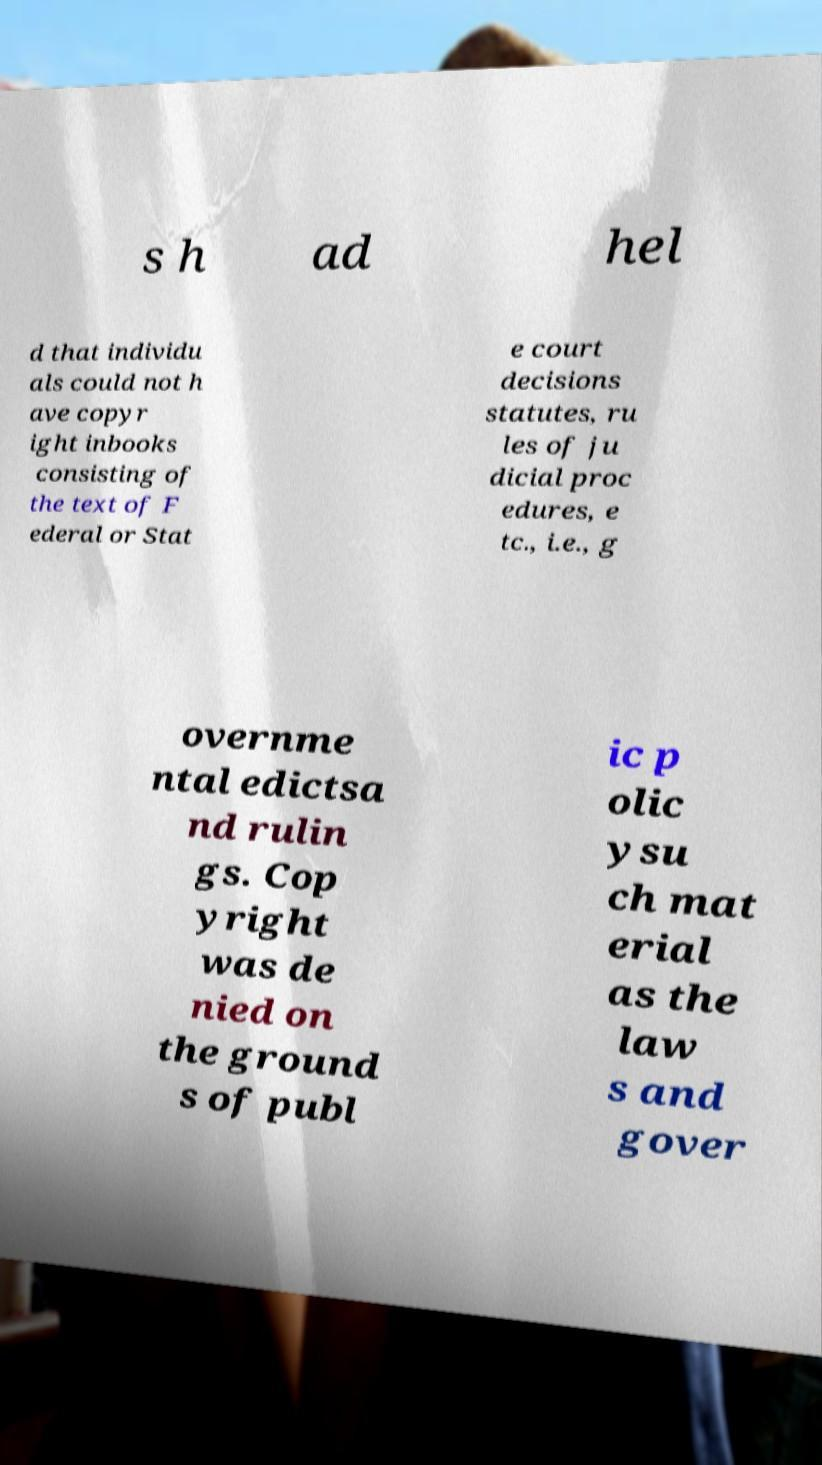For documentation purposes, I need the text within this image transcribed. Could you provide that? s h ad hel d that individu als could not h ave copyr ight inbooks consisting of the text of F ederal or Stat e court decisions statutes, ru les of ju dicial proc edures, e tc., i.e., g overnme ntal edictsa nd rulin gs. Cop yright was de nied on the ground s of publ ic p olic ysu ch mat erial as the law s and gover 